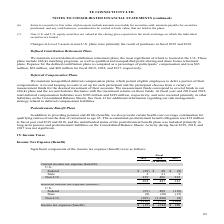From Te Connectivity's financial document, In which years was the Income Tax Expense (Benefit) calculated for? The document contains multiple relevant values: 2019, 2018, 2017. From the document: "2019 2018 2017 2019 2018 2017 2019 2018 2017..." Also, What are the components under U.S. in the table? The document shows two values: Federal and State. From the document: "Federal $ (28) $ 20 $ (9) State 2 21 9..." Also, What are the types of Income Tax Expense (Benefit) in the table? The document shows two values: Current and Deferred. From the document: "Current income tax expense (benefit): Deferred income tax expense (benefit):..." Additionally, Which year was the current income tax expense (benefit) for Non-U.S. the largest? According to the financial document, 2018. The relevant text states: "2019 2018 2017..." Also, can you calculate: What was the change in Current income tax expense (benefit) in 2019 from 2018? Based on the calculation: 203-447, the result is -244 (in millions). This is based on the information: "203 447 322 203 447 322..." The key data points involved are: 203, 447. Also, can you calculate: What was the percentage change in Current income tax expense (benefit) in 2019 from 2018? To answer this question, I need to perform calculations using the financial data. The calculation is: (203-447)/447, which equals -54.59 (percentage). This is based on the information: "203 447 322 203 447 322..." The key data points involved are: 203, 447. 